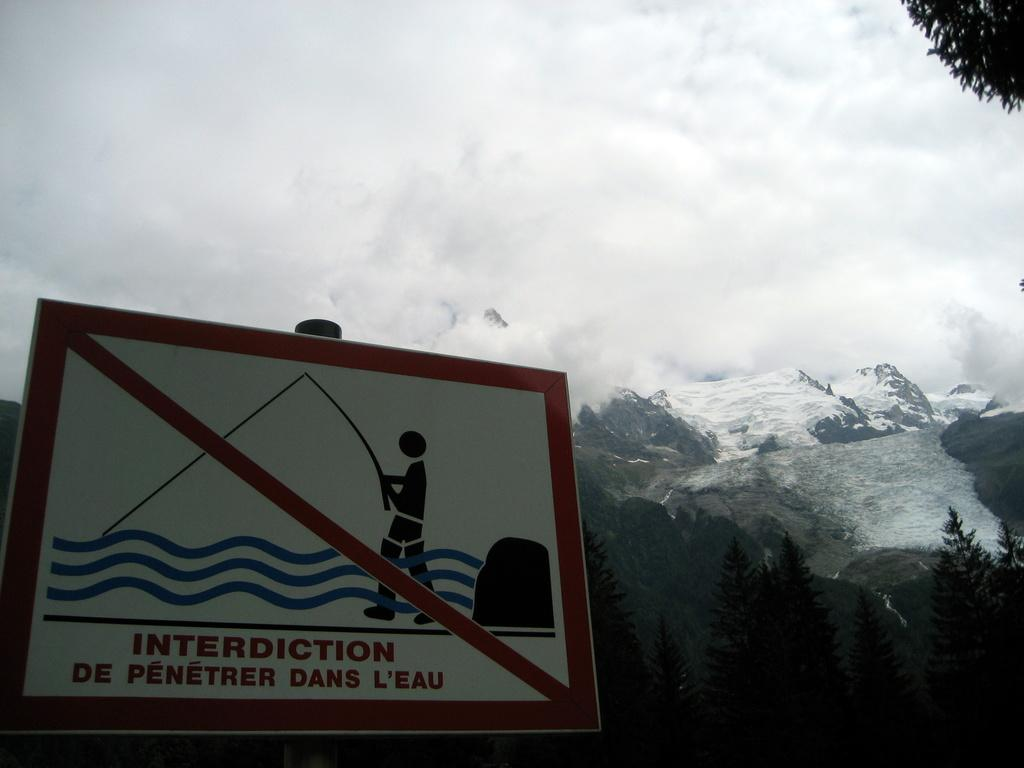<image>
Offer a succinct explanation of the picture presented. A view of sky and mountains in the distance. A sign in the foreground says in french "Interediction de penetrer dans l'eau" with a graphic of a person fishing. 